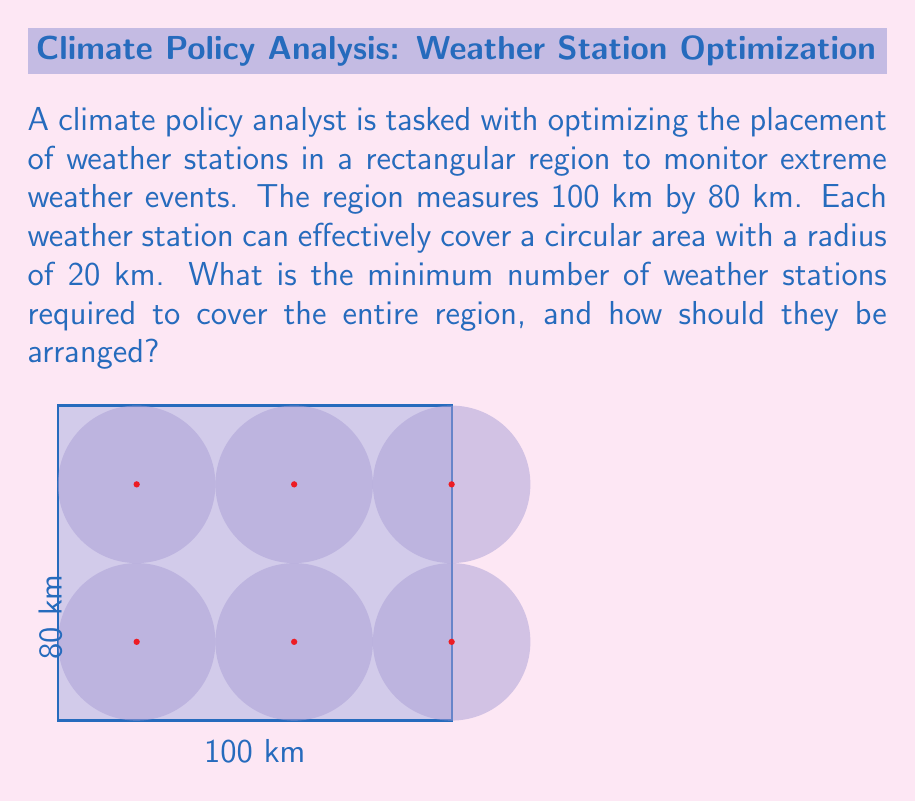What is the answer to this math problem? To solve this problem, we'll follow these steps:

1) First, we need to determine the optimal arrangement of circles (weather station coverage areas) to minimize overlap while covering the entire region.

2) The most efficient arrangement is a grid pattern where the centers of the circles are spaced $\sqrt{3}R$ apart, where $R$ is the radius of each circle. This creates a hexagonal packing pattern.

3) In our case, $R = 20$ km, so the optimal spacing is:

   $$\sqrt{3} \cdot 20 \approx 34.64 \text{ km}$$

4) Now, we need to determine how many stations we can fit along the length and width of the region:

   Length: $100 \text{ km} \div 34.64 \text{ km} \approx 2.89$
   Width: $80 \text{ km} \div 34.64 \text{ km} \approx 2.31$

5) Rounding up (because we need full coverage), we need 3 stations along the length and 3 stations along the width.

6) However, we can optimize this further. By placing the stations in a staggered pattern, we can reduce the number of rows needed:

   3 stations in the first row
   2 stations in the second row
   3 stations in the third row

7) This gives us a total of 8 stations.

8) To arrange them, we place the first row 20 km from the top edge, spaced 40 km apart. The second row is 40 km below the first, with stations centered between those in the first row. The third row follows the same pattern as the first row, 40 km below the second.
Answer: 8 stations arranged in a staggered 3-2-3 pattern 